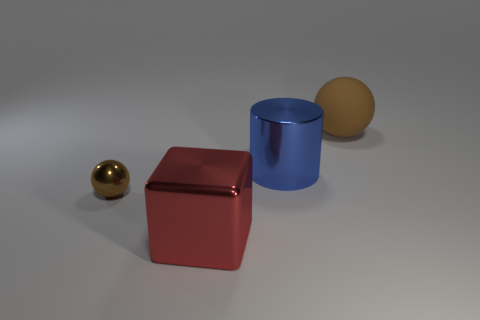What number of metal things are either large red blocks or big blue cylinders?
Make the answer very short. 2. There is a shiny object that is the same color as the large matte object; what is its shape?
Your answer should be very brief. Sphere. What number of small gray metallic blocks are there?
Your answer should be compact. 0. Is the ball that is behind the small metallic object made of the same material as the object to the left of the shiny block?
Your answer should be compact. No. What is the size of the cylinder that is the same material as the small thing?
Your response must be concise. Large. There is a brown object that is in front of the metallic cylinder; what is its shape?
Your answer should be compact. Sphere. There is a big metal object in front of the big blue cylinder; does it have the same color as the large metal thing that is on the right side of the red object?
Give a very brief answer. No. There is a metallic thing that is the same color as the rubber object; what size is it?
Your response must be concise. Small. Are any blue cylinders visible?
Your response must be concise. Yes. What is the shape of the brown thing that is to the right of the big metal thing that is behind the metallic object that is in front of the small brown metal ball?
Your answer should be compact. Sphere. 